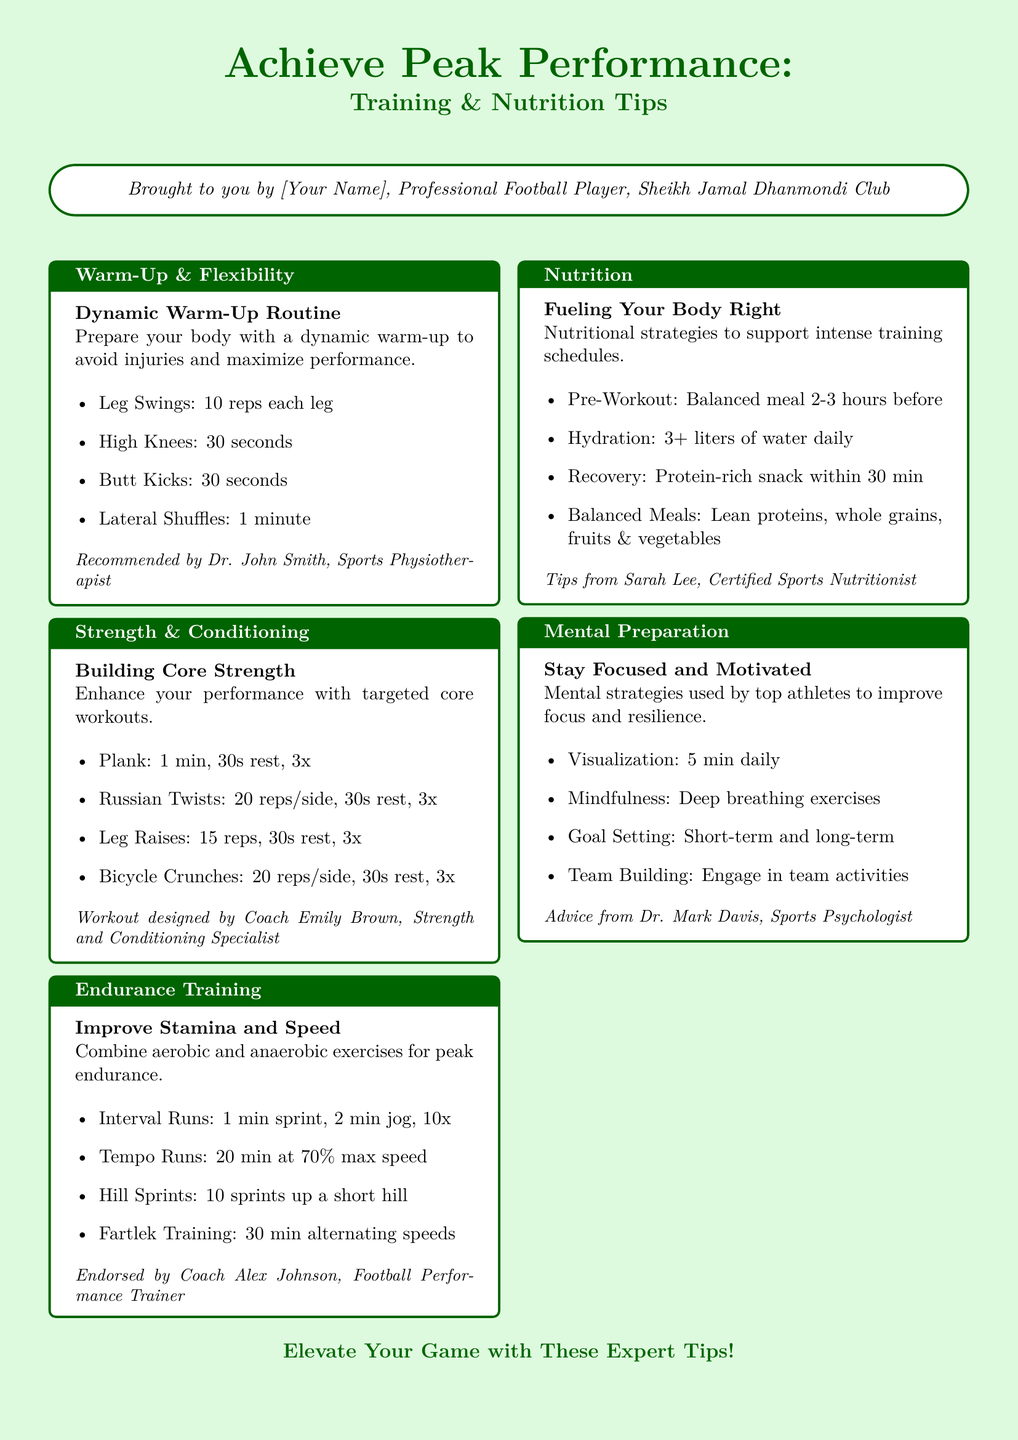what is the title of the flyer? The title of the flyer is provided at the top, highlighting the purpose of the document.
Answer: Achieve Peak Performance: Training & Nutrition Tips who designed the dynamic warm-up routine? The routine is recommended by a professional, identified in the document.
Answer: Dr. John Smith how many repetitions are suggested for Leg Raises in the core strength section? The number of repetitions for Leg Raises is clearly stated in the strength and conditioning section.
Answer: 15 reps what is the recommended hydration amount per day? The nutritional section specifies the hydration requirement for athletes.
Answer: 3+ liters what type of training combines aerobic and anaerobic exercises? The endurance training section discusses the type of training aimed at improving stamina and speed.
Answer: Interval Runs who is the certified sports nutritionist mentioned in the flyer? The flyer shares a professional's name related to sports nutrition.
Answer: Sarah Lee how many times should you perform the Plank exercise? This information is provided in the core strength section under the number of sets.
Answer: 3x what mental preparation strategy is related to deep breathing? This strategy is explicitly mentioned as a way to improve mental focus.
Answer: Mindfulness 